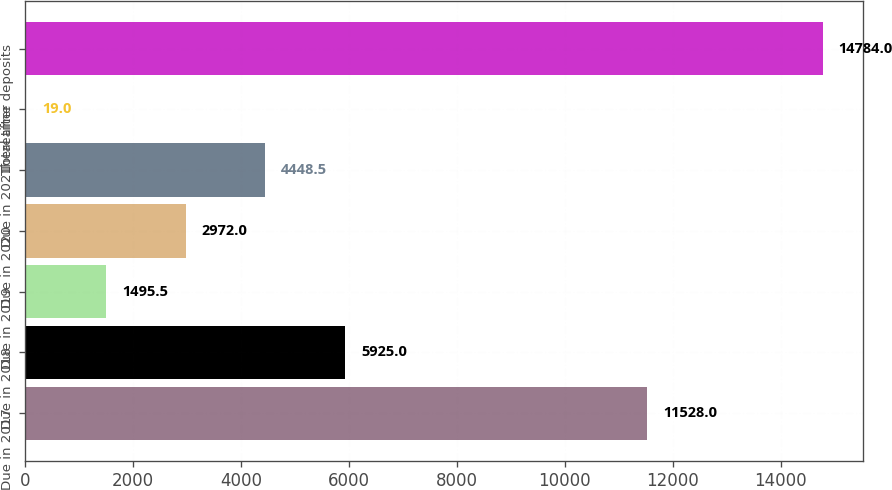Convert chart to OTSL. <chart><loc_0><loc_0><loc_500><loc_500><bar_chart><fcel>Due in 2017<fcel>Due in 2018<fcel>Due in 2019<fcel>Due in 2020<fcel>Due in 2021<fcel>Thereafter<fcel>Total time deposits<nl><fcel>11528<fcel>5925<fcel>1495.5<fcel>2972<fcel>4448.5<fcel>19<fcel>14784<nl></chart> 